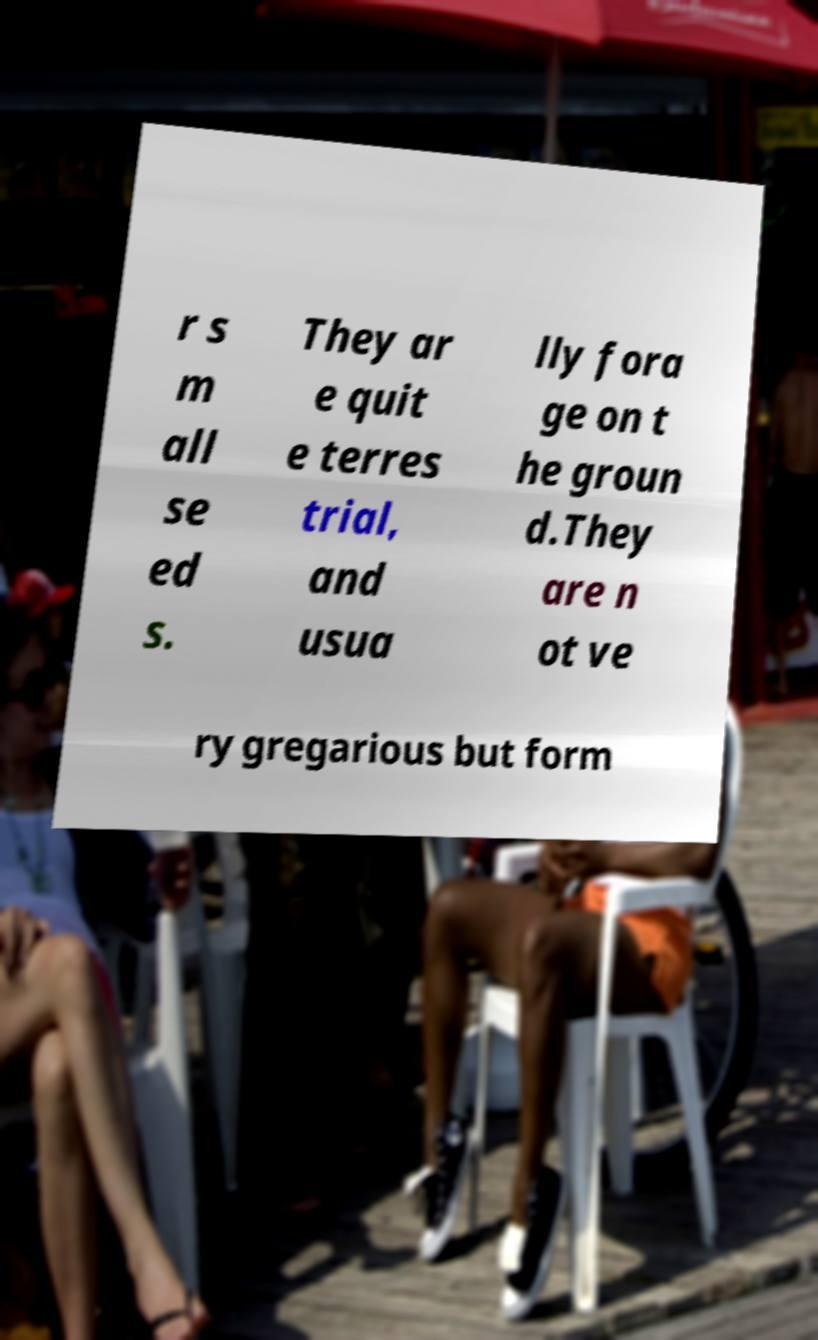I need the written content from this picture converted into text. Can you do that? r s m all se ed s. They ar e quit e terres trial, and usua lly fora ge on t he groun d.They are n ot ve ry gregarious but form 